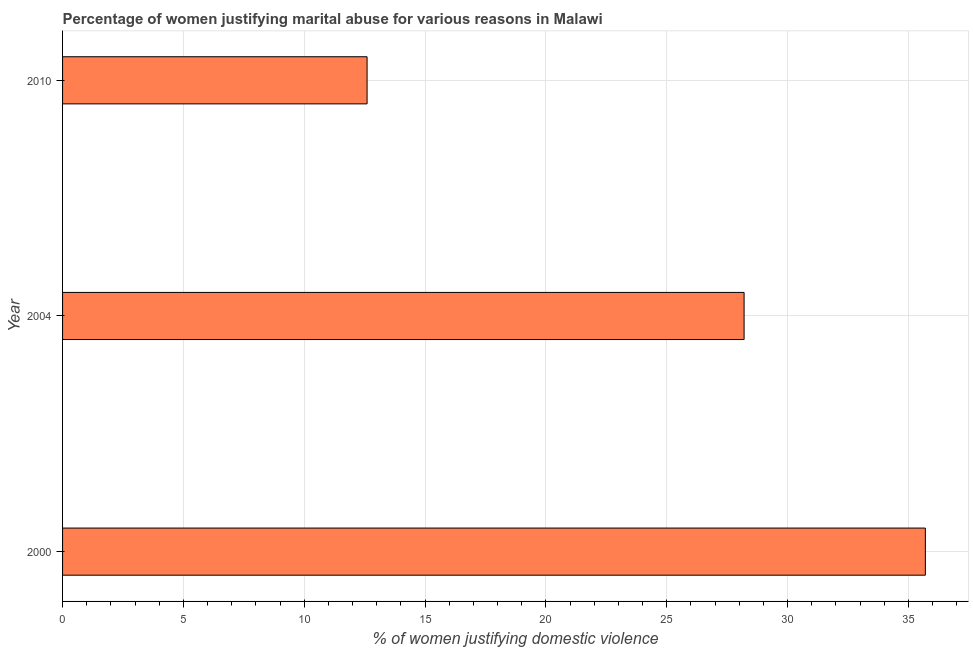Does the graph contain grids?
Provide a succinct answer. Yes. What is the title of the graph?
Keep it short and to the point. Percentage of women justifying marital abuse for various reasons in Malawi. What is the label or title of the X-axis?
Your answer should be very brief. % of women justifying domestic violence. Across all years, what is the maximum percentage of women justifying marital abuse?
Your response must be concise. 35.7. What is the sum of the percentage of women justifying marital abuse?
Your answer should be very brief. 76.5. What is the median percentage of women justifying marital abuse?
Provide a short and direct response. 28.2. In how many years, is the percentage of women justifying marital abuse greater than 18 %?
Provide a succinct answer. 2. Do a majority of the years between 2010 and 2004 (inclusive) have percentage of women justifying marital abuse greater than 10 %?
Offer a very short reply. No. What is the ratio of the percentage of women justifying marital abuse in 2000 to that in 2010?
Keep it short and to the point. 2.83. Is the percentage of women justifying marital abuse in 2000 less than that in 2010?
Keep it short and to the point. No. Is the difference between the percentage of women justifying marital abuse in 2000 and 2010 greater than the difference between any two years?
Your answer should be compact. Yes. What is the difference between the highest and the lowest percentage of women justifying marital abuse?
Ensure brevity in your answer.  23.1. How many bars are there?
Make the answer very short. 3. Are all the bars in the graph horizontal?
Offer a terse response. Yes. How many years are there in the graph?
Offer a terse response. 3. Are the values on the major ticks of X-axis written in scientific E-notation?
Provide a short and direct response. No. What is the % of women justifying domestic violence of 2000?
Provide a succinct answer. 35.7. What is the % of women justifying domestic violence in 2004?
Ensure brevity in your answer.  28.2. What is the difference between the % of women justifying domestic violence in 2000 and 2004?
Ensure brevity in your answer.  7.5. What is the difference between the % of women justifying domestic violence in 2000 and 2010?
Offer a terse response. 23.1. What is the ratio of the % of women justifying domestic violence in 2000 to that in 2004?
Your response must be concise. 1.27. What is the ratio of the % of women justifying domestic violence in 2000 to that in 2010?
Offer a terse response. 2.83. What is the ratio of the % of women justifying domestic violence in 2004 to that in 2010?
Ensure brevity in your answer.  2.24. 